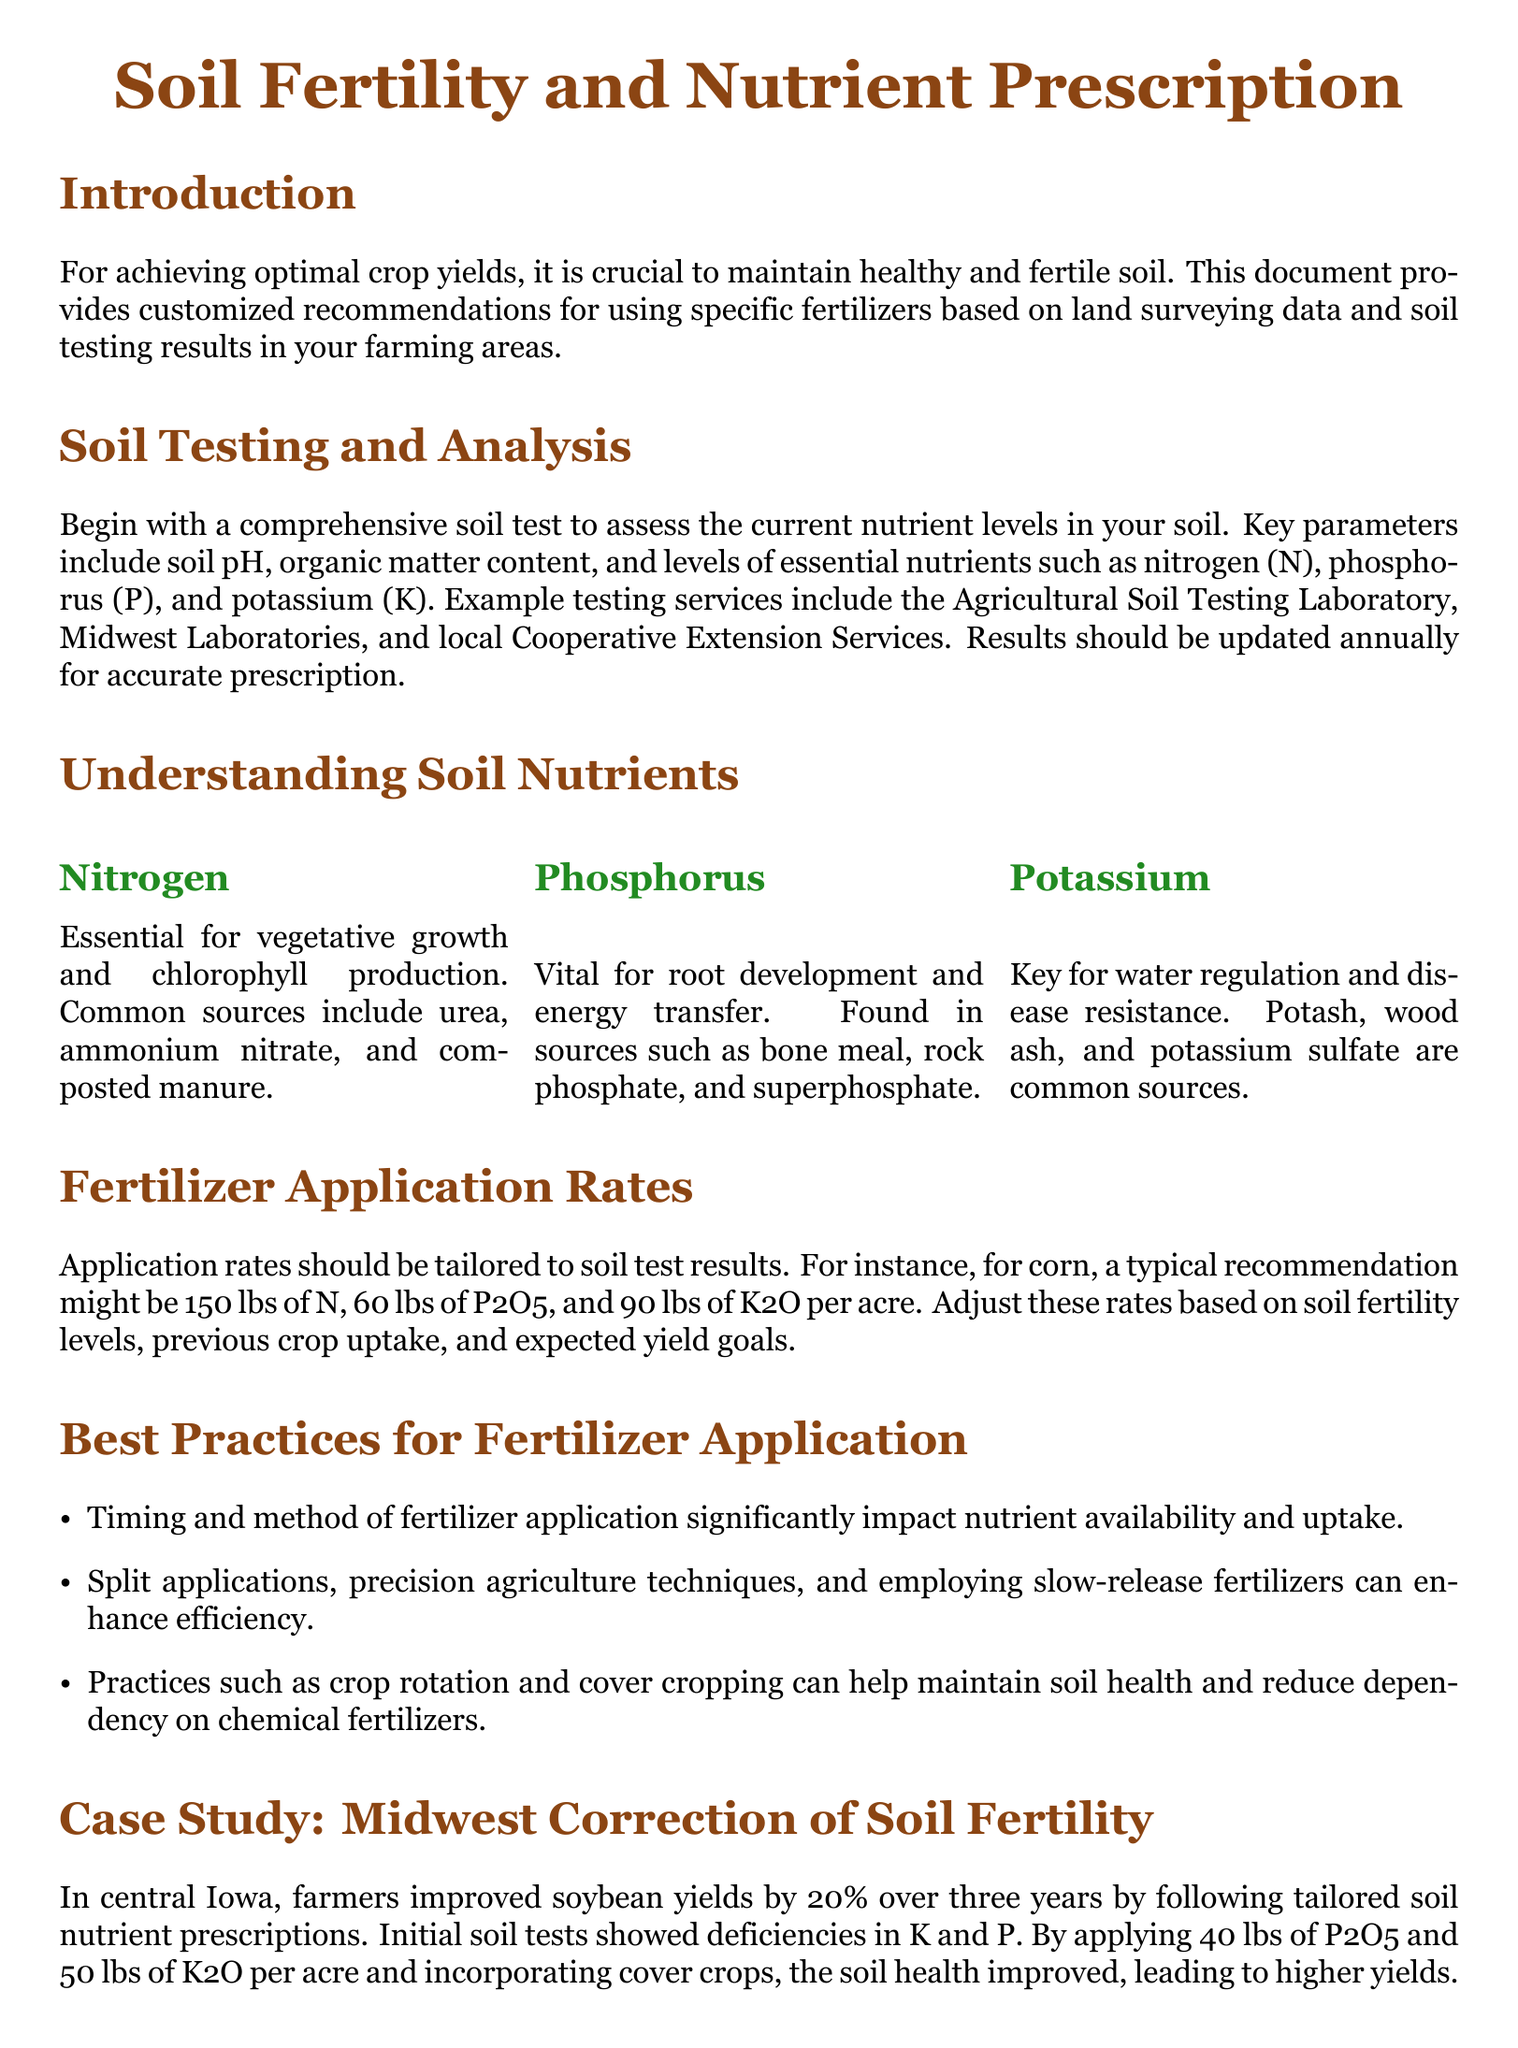What is the document's main focus? The main focus of the document is achieving optimal crop yields through soil fertility and nutrient prescriptions.
Answer: Soil Fertility and Nutrient Prescription What are the key parameters assessed in soil testing? Key parameters include soil pH, organic matter content, and levels of essential nutrients.
Answer: pH, organic matter, essential nutrients What is a common source of nitrogen? The document lists several common sources of nitrogen for fertilizer use. One specific example is urea.
Answer: Urea What should the typical recommendation be for potassium application rate per acre for corn? The document states a typical application rate for potassium is specified in pounds per acre for corn.
Answer: 90 lbs of K2O What agricultural practice can help maintain soil health and reduce chemical fertilizer dependency? The document highlights a practice that contributes to soil health while decreasing the need for fertilizers.
Answer: Cover cropping How much phosphorus should be applied for optimal soybean yield improvement in the case study? The case study specifies the quantity of phosphorus applied to improve soybean yields.
Answer: 40 lbs of P2O5 Which organization provides soil testing services mentioned in the document? The document contains references to various organizations that offer soil testing. One mentioned is the Agricultural Soil Testing Laboratory.
Answer: Agricultural Soil Testing Laboratory What was the percentage increase in soybean yields in the case study over three years? According to the case study, the yield improvement is explicitly stated as a percentage over a set period.
Answer: 20% 